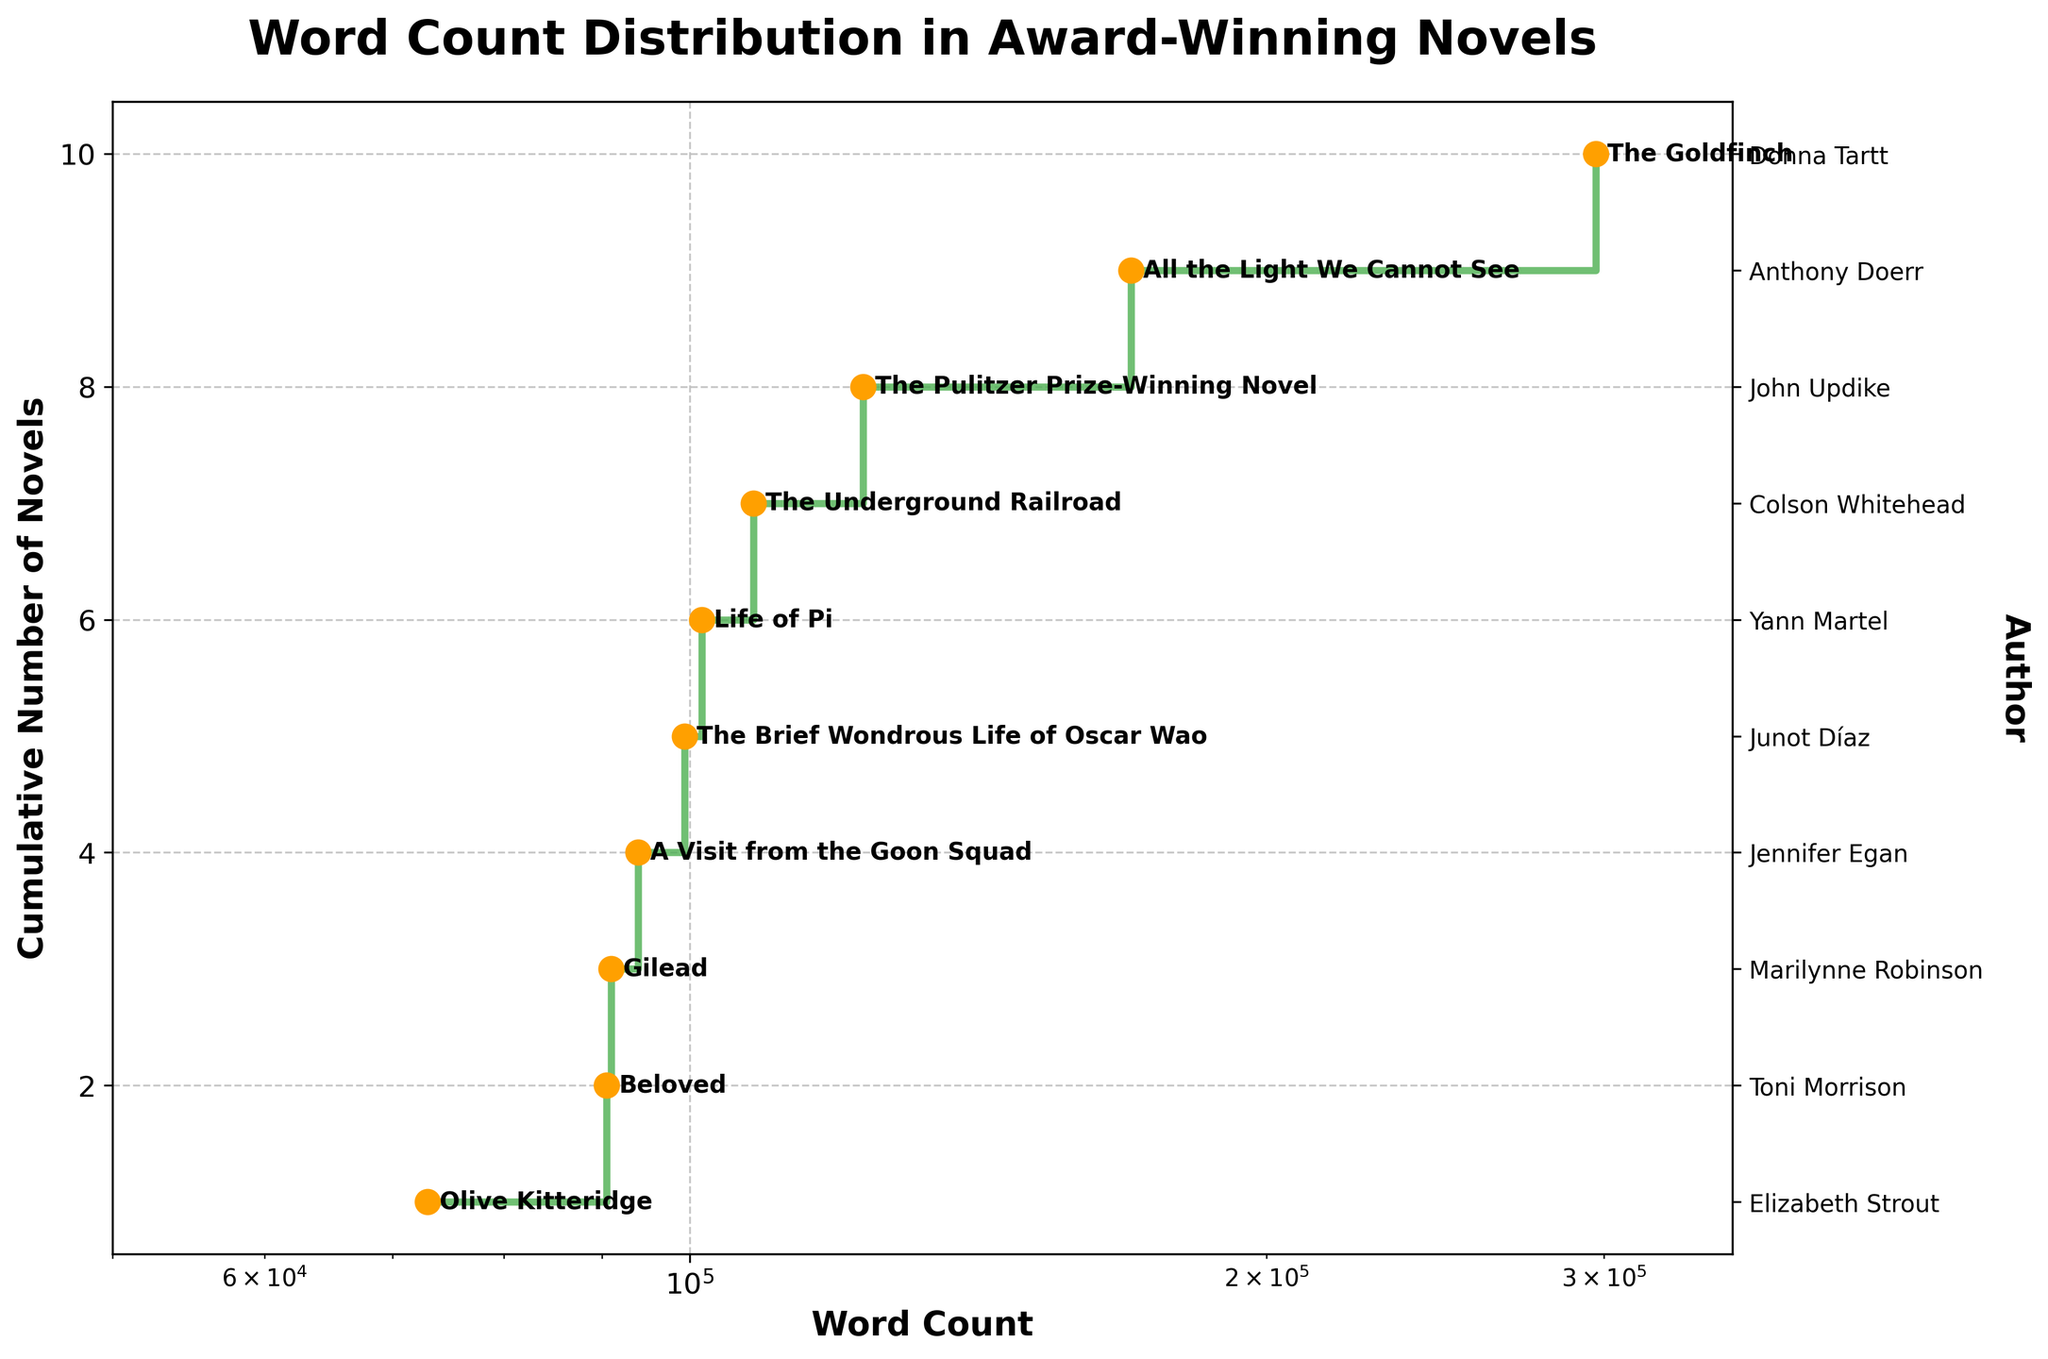what is the title of the plot? The title of the plot is shown at the top center of the figure. The title clearly states what the plot is about.
Answer: Word Count Distribution in Award-Winning Novels how many novels are included in the plot? You can determine the number of novels by looking at the y-axis, which shows the cumulative number of novels. The highest value on the y-axis indicates the total count.
Answer: 10 which novel has the highest word count? The novel with the highest word count is marked at the far right of the x-axis. Annotating the titles makes it easy to identify.
Answer: The Goldfinch what is the word count range represented on the x-axis? The x-axis starts and stops at certain values, often custom-configured for better visualization. You can read these values directly from the axis.
Answer: 50,000 to 350,000 how does the word count of "Life of Pi" compare to "Olive Kitteridge"? "Life of Pi" and "Olive Kitteridge" are annotated on the figure. Their word counts can be compared by checking their positions along the x-axis.
Answer: Life of Pi > Olive Kitteridge what is the median word count of the novels? To find the median, locate the middle value in the sorted order. With 10 novels, the median is the average of the 5th and 6th novel in the sorted list.
Answer: 99,200 which novel falls closest to the middle word count? By finding the median word count and identifying the corresponding title from the plot, you can determine the novel closest to this value.
Answer: The Brief Wondrous Life of Oscar Wao what trends do you observe as the word count increases? Observe the overall shape and direction of the step plot. This can provide insight into how word counts distribute among the novels, e.g., if they increase evenly or have outliers.
Answer: Increases with a few large jumps how is the author information displayed on the plot? The right y-axis is used to display the author names. Labels align with the y-values representing each novel.
Answer: Along the right y-axis how does adding a log scale to the x-axis improve this visualization? A log scale can spread out data points more evenly, especially when the data spans several orders of magnitude, making it easier to distinguish individual values.
Answer: Better distinguishes word counts 